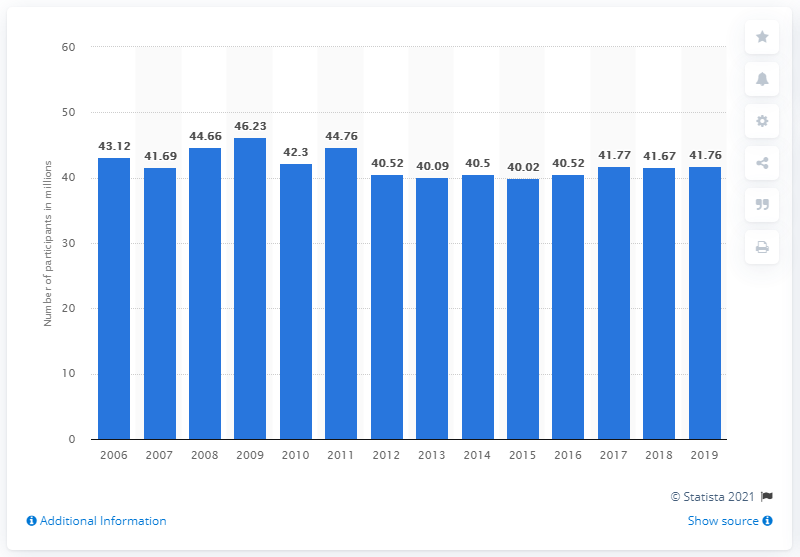Highlight a few significant elements in this photo. There were 41.76 million participants in camping in the United States in 2019. 